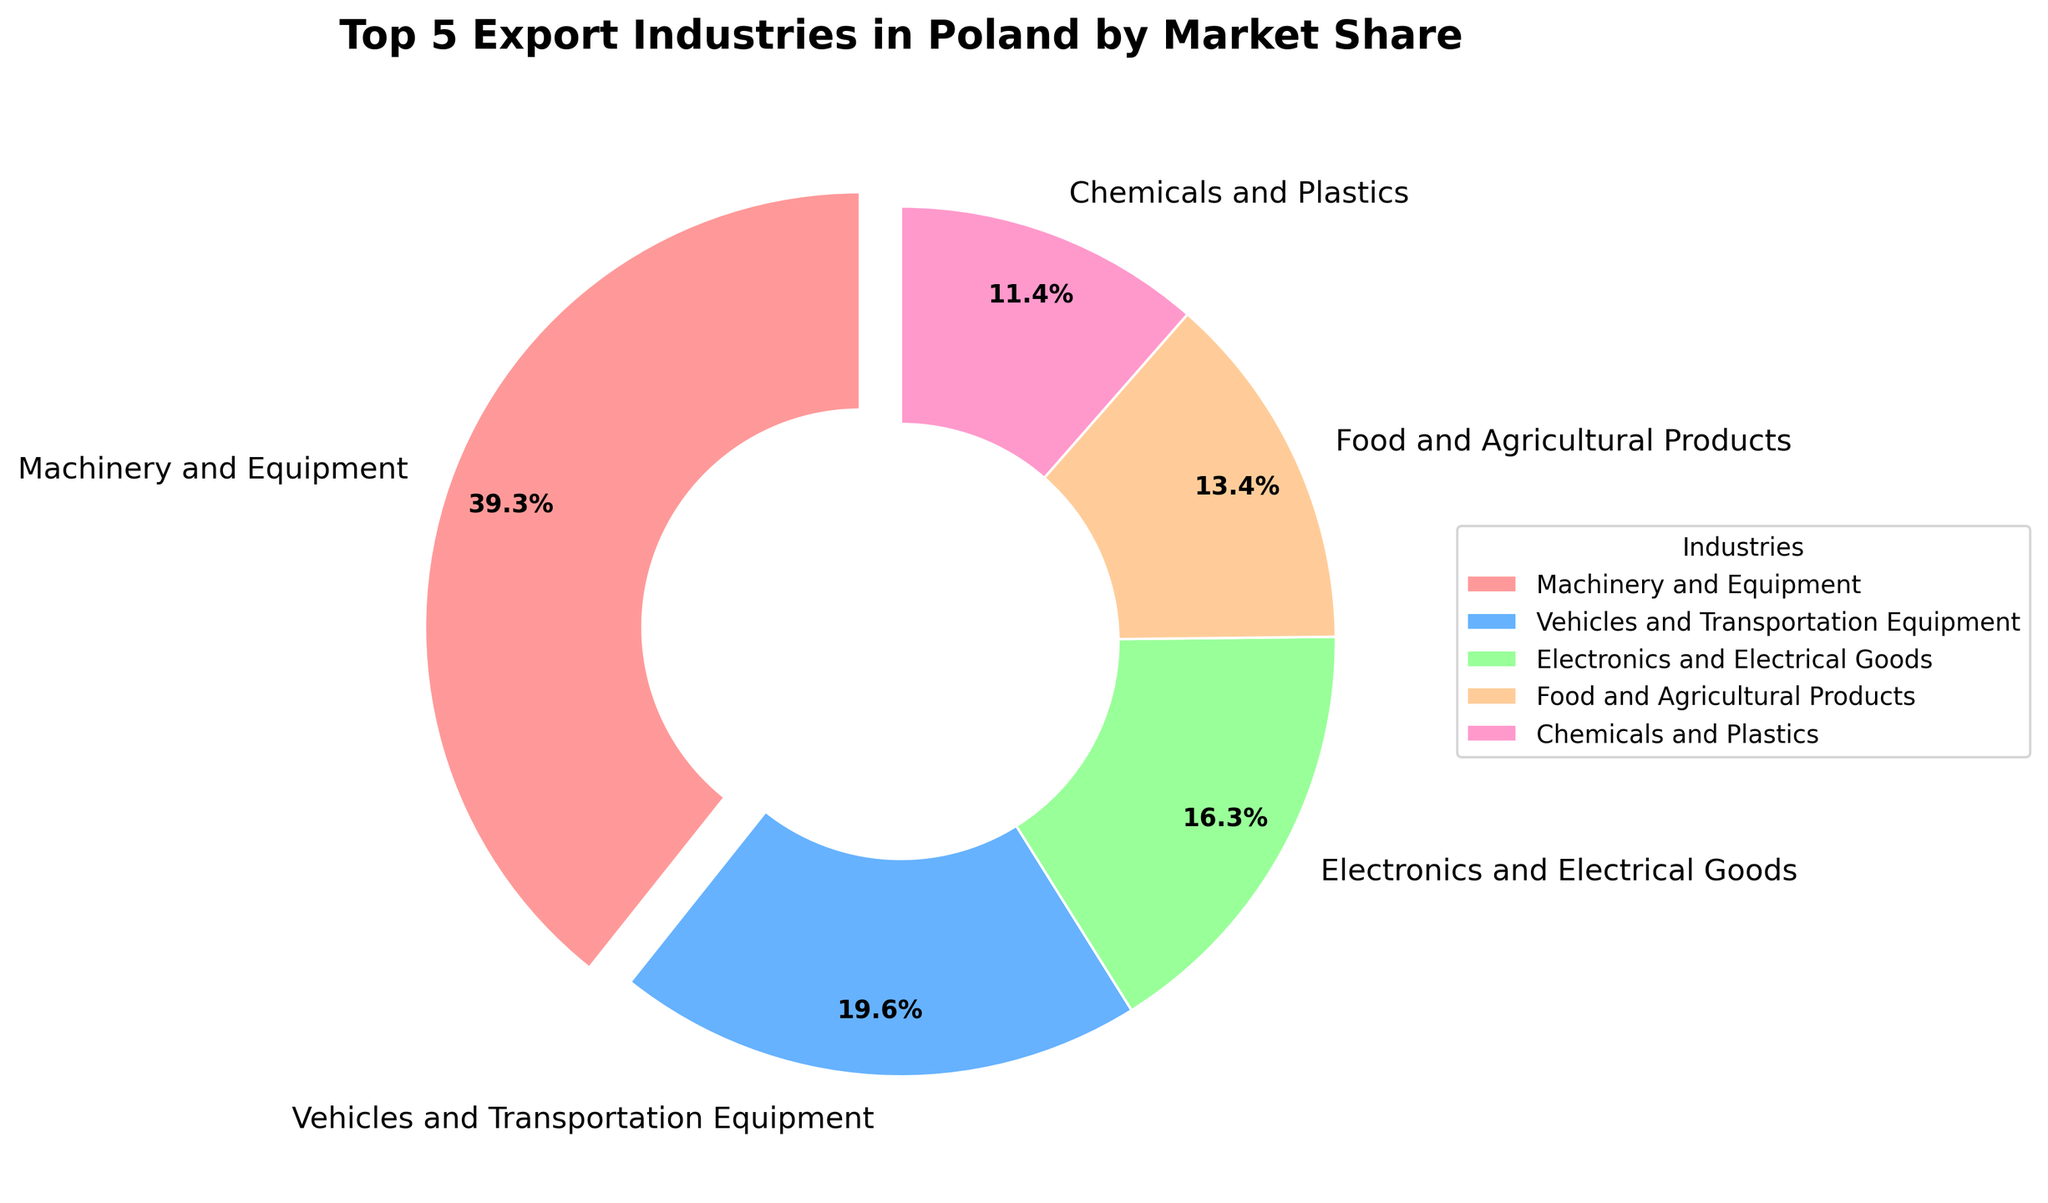What is the market share of Machinery and Equipment? The figure shows that Machinery and Equipment holds 28.5% market share by looking at the label next to the respective wedge in the pie chart.
Answer: 28.5% Which industry has the second-largest market share and what is its percentage? By examining the pie chart, Vehicles and Transportation Equipment is the second-largest with 14.2%, as indicated by the label.
Answer: Vehicles and Transportation Equipment, 14.2% What is the combined market share of Food and Agricultural Products and Chemicals and Plastics? Adding the market shares of Food and Agricultural Products (9.7%) and Chemicals and Plastics (8.3%) gives 9.7% + 8.3% = 18%.
Answer: 18% Which industry has the smallest market share and what color is associated with it in the pie chart? Chemicals and Plastics has the smallest market share at 8.3%, and it is represented by a pink wedge.
Answer: Chemicals and Plastics, pink What is the difference in market share between Electronics and Electrical Goods and Vehicles and Transportation Equipment? Subtracting the market share of Electronics and Electrical Goods (11.8%) from that of Vehicles and Transportation Equipment (14.2%) gives 14.2% - 11.8% = 2.4%.
Answer: 2.4% What proportion of the export market do the top two industries combined hold? Adding the market shares of Machinery and Equipment (28.5%) and Vehicles and Transportation Equipment (14.2%) gives 28.5% + 14.2% = 42.7%.
Answer: 42.7% Which sector has a slightly smaller market share than Electronics and Electrical Goods, and what is the exact difference in percentage? Food and Agricultural Products comes after Electronics and Electrical Goods with 9.7%. The difference is 11.8% - 9.7% = 2.1%.
Answer: Food and Agricultural Products, 2.1% 